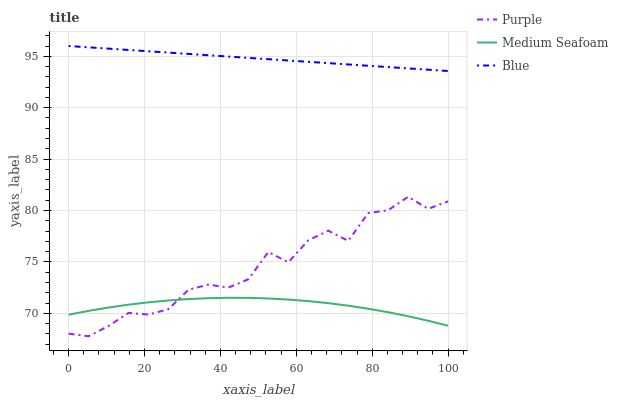Does Medium Seafoam have the minimum area under the curve?
Answer yes or no. Yes. Does Blue have the maximum area under the curve?
Answer yes or no. Yes. Does Blue have the minimum area under the curve?
Answer yes or no. No. Does Medium Seafoam have the maximum area under the curve?
Answer yes or no. No. Is Blue the smoothest?
Answer yes or no. Yes. Is Purple the roughest?
Answer yes or no. Yes. Is Medium Seafoam the smoothest?
Answer yes or no. No. Is Medium Seafoam the roughest?
Answer yes or no. No. Does Medium Seafoam have the lowest value?
Answer yes or no. No. Does Medium Seafoam have the highest value?
Answer yes or no. No. Is Purple less than Blue?
Answer yes or no. Yes. Is Blue greater than Medium Seafoam?
Answer yes or no. Yes. Does Purple intersect Blue?
Answer yes or no. No. 